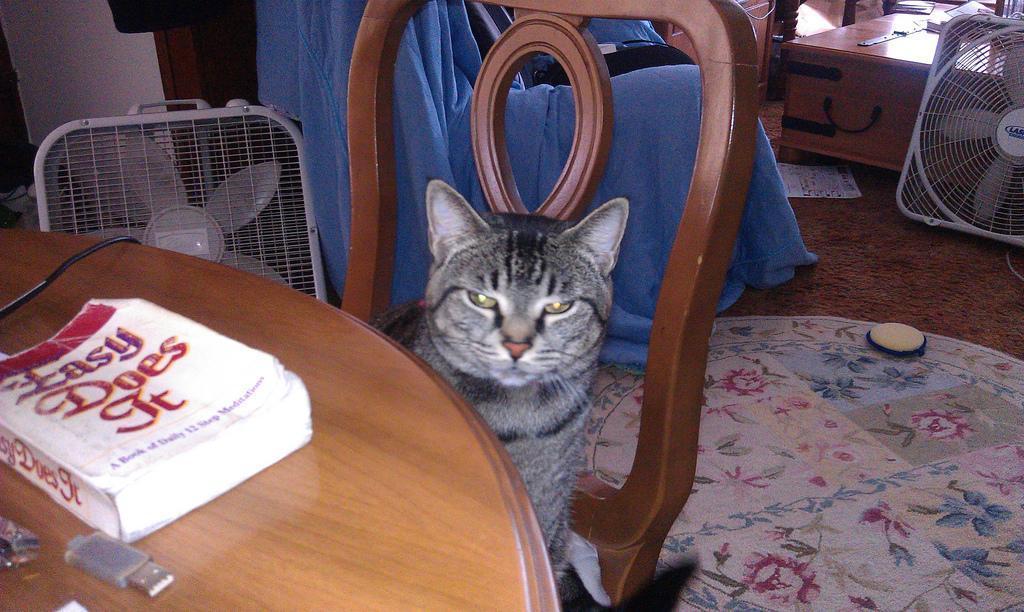How many white fans are in the picture?
Give a very brief answer. 2. How many fans?
Give a very brief answer. 2. How many cats?
Give a very brief answer. 1. How many cats sitting on a chair?
Give a very brief answer. 1. 